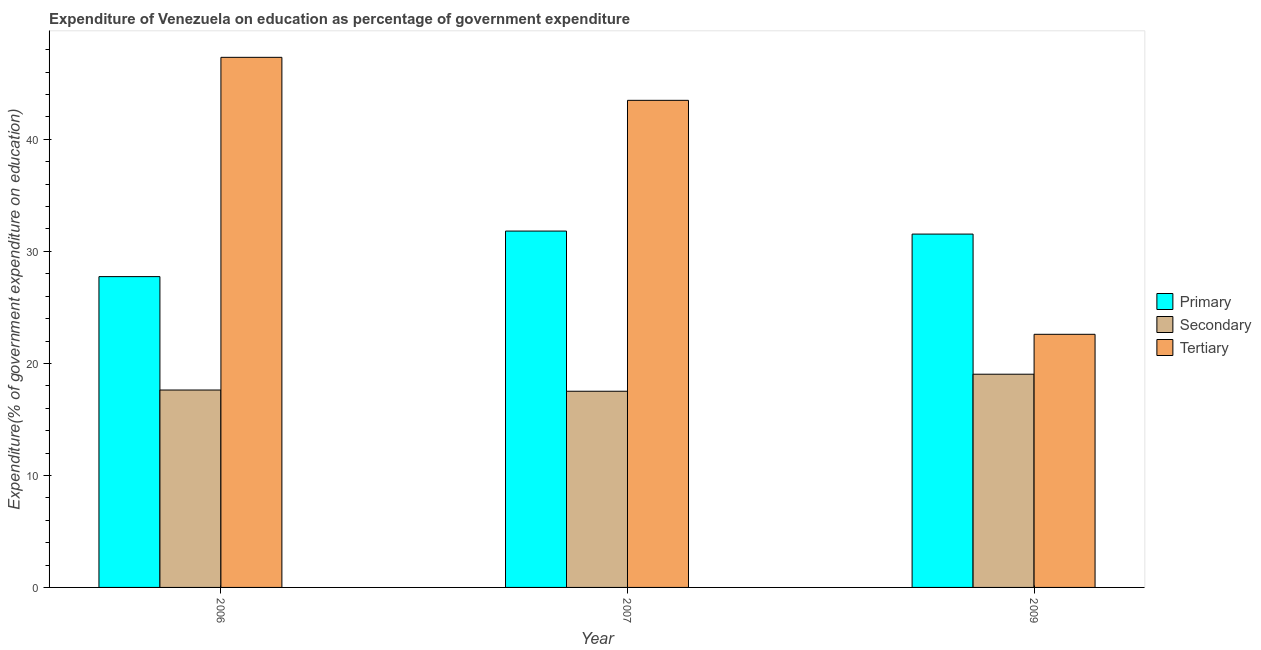Are the number of bars per tick equal to the number of legend labels?
Give a very brief answer. Yes. Are the number of bars on each tick of the X-axis equal?
Your response must be concise. Yes. How many bars are there on the 1st tick from the left?
Ensure brevity in your answer.  3. What is the label of the 2nd group of bars from the left?
Your response must be concise. 2007. In how many cases, is the number of bars for a given year not equal to the number of legend labels?
Offer a terse response. 0. What is the expenditure on primary education in 2007?
Your response must be concise. 31.81. Across all years, what is the maximum expenditure on primary education?
Your response must be concise. 31.81. Across all years, what is the minimum expenditure on secondary education?
Give a very brief answer. 17.52. What is the total expenditure on tertiary education in the graph?
Offer a very short reply. 113.41. What is the difference between the expenditure on primary education in 2006 and that in 2009?
Offer a very short reply. -3.8. What is the difference between the expenditure on primary education in 2007 and the expenditure on tertiary education in 2006?
Offer a very short reply. 4.07. What is the average expenditure on tertiary education per year?
Ensure brevity in your answer.  37.8. In the year 2006, what is the difference between the expenditure on secondary education and expenditure on primary education?
Your response must be concise. 0. In how many years, is the expenditure on tertiary education greater than 14 %?
Your answer should be compact. 3. What is the ratio of the expenditure on tertiary education in 2006 to that in 2007?
Your answer should be compact. 1.09. Is the expenditure on tertiary education in 2007 less than that in 2009?
Make the answer very short. No. What is the difference between the highest and the second highest expenditure on secondary education?
Provide a short and direct response. 1.41. What is the difference between the highest and the lowest expenditure on primary education?
Make the answer very short. 4.07. In how many years, is the expenditure on primary education greater than the average expenditure on primary education taken over all years?
Ensure brevity in your answer.  2. Is the sum of the expenditure on secondary education in 2006 and 2009 greater than the maximum expenditure on primary education across all years?
Your response must be concise. Yes. What does the 2nd bar from the left in 2006 represents?
Provide a succinct answer. Secondary. What does the 2nd bar from the right in 2006 represents?
Your answer should be very brief. Secondary. How many bars are there?
Provide a short and direct response. 9. Are all the bars in the graph horizontal?
Your answer should be very brief. No. What is the difference between two consecutive major ticks on the Y-axis?
Ensure brevity in your answer.  10. Does the graph contain any zero values?
Your response must be concise. No. Does the graph contain grids?
Your answer should be compact. No. Where does the legend appear in the graph?
Offer a very short reply. Center right. How are the legend labels stacked?
Your response must be concise. Vertical. What is the title of the graph?
Ensure brevity in your answer.  Expenditure of Venezuela on education as percentage of government expenditure. Does "Ireland" appear as one of the legend labels in the graph?
Provide a succinct answer. No. What is the label or title of the X-axis?
Your response must be concise. Year. What is the label or title of the Y-axis?
Offer a terse response. Expenditure(% of government expenditure on education). What is the Expenditure(% of government expenditure on education) of Primary in 2006?
Offer a very short reply. 27.75. What is the Expenditure(% of government expenditure on education) in Secondary in 2006?
Your response must be concise. 17.62. What is the Expenditure(% of government expenditure on education) of Tertiary in 2006?
Provide a short and direct response. 47.33. What is the Expenditure(% of government expenditure on education) in Primary in 2007?
Your response must be concise. 31.81. What is the Expenditure(% of government expenditure on education) in Secondary in 2007?
Your response must be concise. 17.52. What is the Expenditure(% of government expenditure on education) in Tertiary in 2007?
Offer a terse response. 43.49. What is the Expenditure(% of government expenditure on education) of Primary in 2009?
Keep it short and to the point. 31.55. What is the Expenditure(% of government expenditure on education) of Secondary in 2009?
Your answer should be very brief. 19.04. What is the Expenditure(% of government expenditure on education) of Tertiary in 2009?
Make the answer very short. 22.6. Across all years, what is the maximum Expenditure(% of government expenditure on education) of Primary?
Give a very brief answer. 31.81. Across all years, what is the maximum Expenditure(% of government expenditure on education) in Secondary?
Provide a short and direct response. 19.04. Across all years, what is the maximum Expenditure(% of government expenditure on education) of Tertiary?
Ensure brevity in your answer.  47.33. Across all years, what is the minimum Expenditure(% of government expenditure on education) of Primary?
Offer a very short reply. 27.75. Across all years, what is the minimum Expenditure(% of government expenditure on education) of Secondary?
Your answer should be very brief. 17.52. Across all years, what is the minimum Expenditure(% of government expenditure on education) of Tertiary?
Ensure brevity in your answer.  22.6. What is the total Expenditure(% of government expenditure on education) in Primary in the graph?
Ensure brevity in your answer.  91.11. What is the total Expenditure(% of government expenditure on education) in Secondary in the graph?
Provide a succinct answer. 54.17. What is the total Expenditure(% of government expenditure on education) in Tertiary in the graph?
Your answer should be compact. 113.41. What is the difference between the Expenditure(% of government expenditure on education) of Primary in 2006 and that in 2007?
Make the answer very short. -4.07. What is the difference between the Expenditure(% of government expenditure on education) of Secondary in 2006 and that in 2007?
Keep it short and to the point. 0.11. What is the difference between the Expenditure(% of government expenditure on education) of Tertiary in 2006 and that in 2007?
Provide a succinct answer. 3.84. What is the difference between the Expenditure(% of government expenditure on education) of Primary in 2006 and that in 2009?
Give a very brief answer. -3.8. What is the difference between the Expenditure(% of government expenditure on education) in Secondary in 2006 and that in 2009?
Ensure brevity in your answer.  -1.41. What is the difference between the Expenditure(% of government expenditure on education) of Tertiary in 2006 and that in 2009?
Your answer should be compact. 24.73. What is the difference between the Expenditure(% of government expenditure on education) of Primary in 2007 and that in 2009?
Your answer should be compact. 0.27. What is the difference between the Expenditure(% of government expenditure on education) of Secondary in 2007 and that in 2009?
Your answer should be compact. -1.52. What is the difference between the Expenditure(% of government expenditure on education) in Tertiary in 2007 and that in 2009?
Provide a succinct answer. 20.89. What is the difference between the Expenditure(% of government expenditure on education) of Primary in 2006 and the Expenditure(% of government expenditure on education) of Secondary in 2007?
Provide a short and direct response. 10.23. What is the difference between the Expenditure(% of government expenditure on education) in Primary in 2006 and the Expenditure(% of government expenditure on education) in Tertiary in 2007?
Offer a terse response. -15.74. What is the difference between the Expenditure(% of government expenditure on education) of Secondary in 2006 and the Expenditure(% of government expenditure on education) of Tertiary in 2007?
Make the answer very short. -25.86. What is the difference between the Expenditure(% of government expenditure on education) in Primary in 2006 and the Expenditure(% of government expenditure on education) in Secondary in 2009?
Your answer should be very brief. 8.71. What is the difference between the Expenditure(% of government expenditure on education) in Primary in 2006 and the Expenditure(% of government expenditure on education) in Tertiary in 2009?
Your response must be concise. 5.15. What is the difference between the Expenditure(% of government expenditure on education) in Secondary in 2006 and the Expenditure(% of government expenditure on education) in Tertiary in 2009?
Provide a succinct answer. -4.98. What is the difference between the Expenditure(% of government expenditure on education) of Primary in 2007 and the Expenditure(% of government expenditure on education) of Secondary in 2009?
Ensure brevity in your answer.  12.78. What is the difference between the Expenditure(% of government expenditure on education) in Primary in 2007 and the Expenditure(% of government expenditure on education) in Tertiary in 2009?
Keep it short and to the point. 9.22. What is the difference between the Expenditure(% of government expenditure on education) in Secondary in 2007 and the Expenditure(% of government expenditure on education) in Tertiary in 2009?
Your response must be concise. -5.08. What is the average Expenditure(% of government expenditure on education) of Primary per year?
Provide a short and direct response. 30.37. What is the average Expenditure(% of government expenditure on education) in Secondary per year?
Your answer should be very brief. 18.06. What is the average Expenditure(% of government expenditure on education) in Tertiary per year?
Offer a very short reply. 37.8. In the year 2006, what is the difference between the Expenditure(% of government expenditure on education) in Primary and Expenditure(% of government expenditure on education) in Secondary?
Your response must be concise. 10.13. In the year 2006, what is the difference between the Expenditure(% of government expenditure on education) in Primary and Expenditure(% of government expenditure on education) in Tertiary?
Keep it short and to the point. -19.58. In the year 2006, what is the difference between the Expenditure(% of government expenditure on education) of Secondary and Expenditure(% of government expenditure on education) of Tertiary?
Provide a short and direct response. -29.7. In the year 2007, what is the difference between the Expenditure(% of government expenditure on education) of Primary and Expenditure(% of government expenditure on education) of Secondary?
Your answer should be very brief. 14.3. In the year 2007, what is the difference between the Expenditure(% of government expenditure on education) of Primary and Expenditure(% of government expenditure on education) of Tertiary?
Provide a short and direct response. -11.67. In the year 2007, what is the difference between the Expenditure(% of government expenditure on education) in Secondary and Expenditure(% of government expenditure on education) in Tertiary?
Provide a short and direct response. -25.97. In the year 2009, what is the difference between the Expenditure(% of government expenditure on education) in Primary and Expenditure(% of government expenditure on education) in Secondary?
Provide a succinct answer. 12.51. In the year 2009, what is the difference between the Expenditure(% of government expenditure on education) in Primary and Expenditure(% of government expenditure on education) in Tertiary?
Your response must be concise. 8.95. In the year 2009, what is the difference between the Expenditure(% of government expenditure on education) of Secondary and Expenditure(% of government expenditure on education) of Tertiary?
Keep it short and to the point. -3.56. What is the ratio of the Expenditure(% of government expenditure on education) in Primary in 2006 to that in 2007?
Your response must be concise. 0.87. What is the ratio of the Expenditure(% of government expenditure on education) of Tertiary in 2006 to that in 2007?
Your answer should be compact. 1.09. What is the ratio of the Expenditure(% of government expenditure on education) of Primary in 2006 to that in 2009?
Offer a very short reply. 0.88. What is the ratio of the Expenditure(% of government expenditure on education) of Secondary in 2006 to that in 2009?
Provide a succinct answer. 0.93. What is the ratio of the Expenditure(% of government expenditure on education) in Tertiary in 2006 to that in 2009?
Give a very brief answer. 2.09. What is the ratio of the Expenditure(% of government expenditure on education) in Primary in 2007 to that in 2009?
Keep it short and to the point. 1.01. What is the ratio of the Expenditure(% of government expenditure on education) of Secondary in 2007 to that in 2009?
Give a very brief answer. 0.92. What is the ratio of the Expenditure(% of government expenditure on education) of Tertiary in 2007 to that in 2009?
Provide a short and direct response. 1.92. What is the difference between the highest and the second highest Expenditure(% of government expenditure on education) of Primary?
Ensure brevity in your answer.  0.27. What is the difference between the highest and the second highest Expenditure(% of government expenditure on education) of Secondary?
Your answer should be compact. 1.41. What is the difference between the highest and the second highest Expenditure(% of government expenditure on education) of Tertiary?
Ensure brevity in your answer.  3.84. What is the difference between the highest and the lowest Expenditure(% of government expenditure on education) in Primary?
Provide a short and direct response. 4.07. What is the difference between the highest and the lowest Expenditure(% of government expenditure on education) of Secondary?
Your response must be concise. 1.52. What is the difference between the highest and the lowest Expenditure(% of government expenditure on education) of Tertiary?
Make the answer very short. 24.73. 